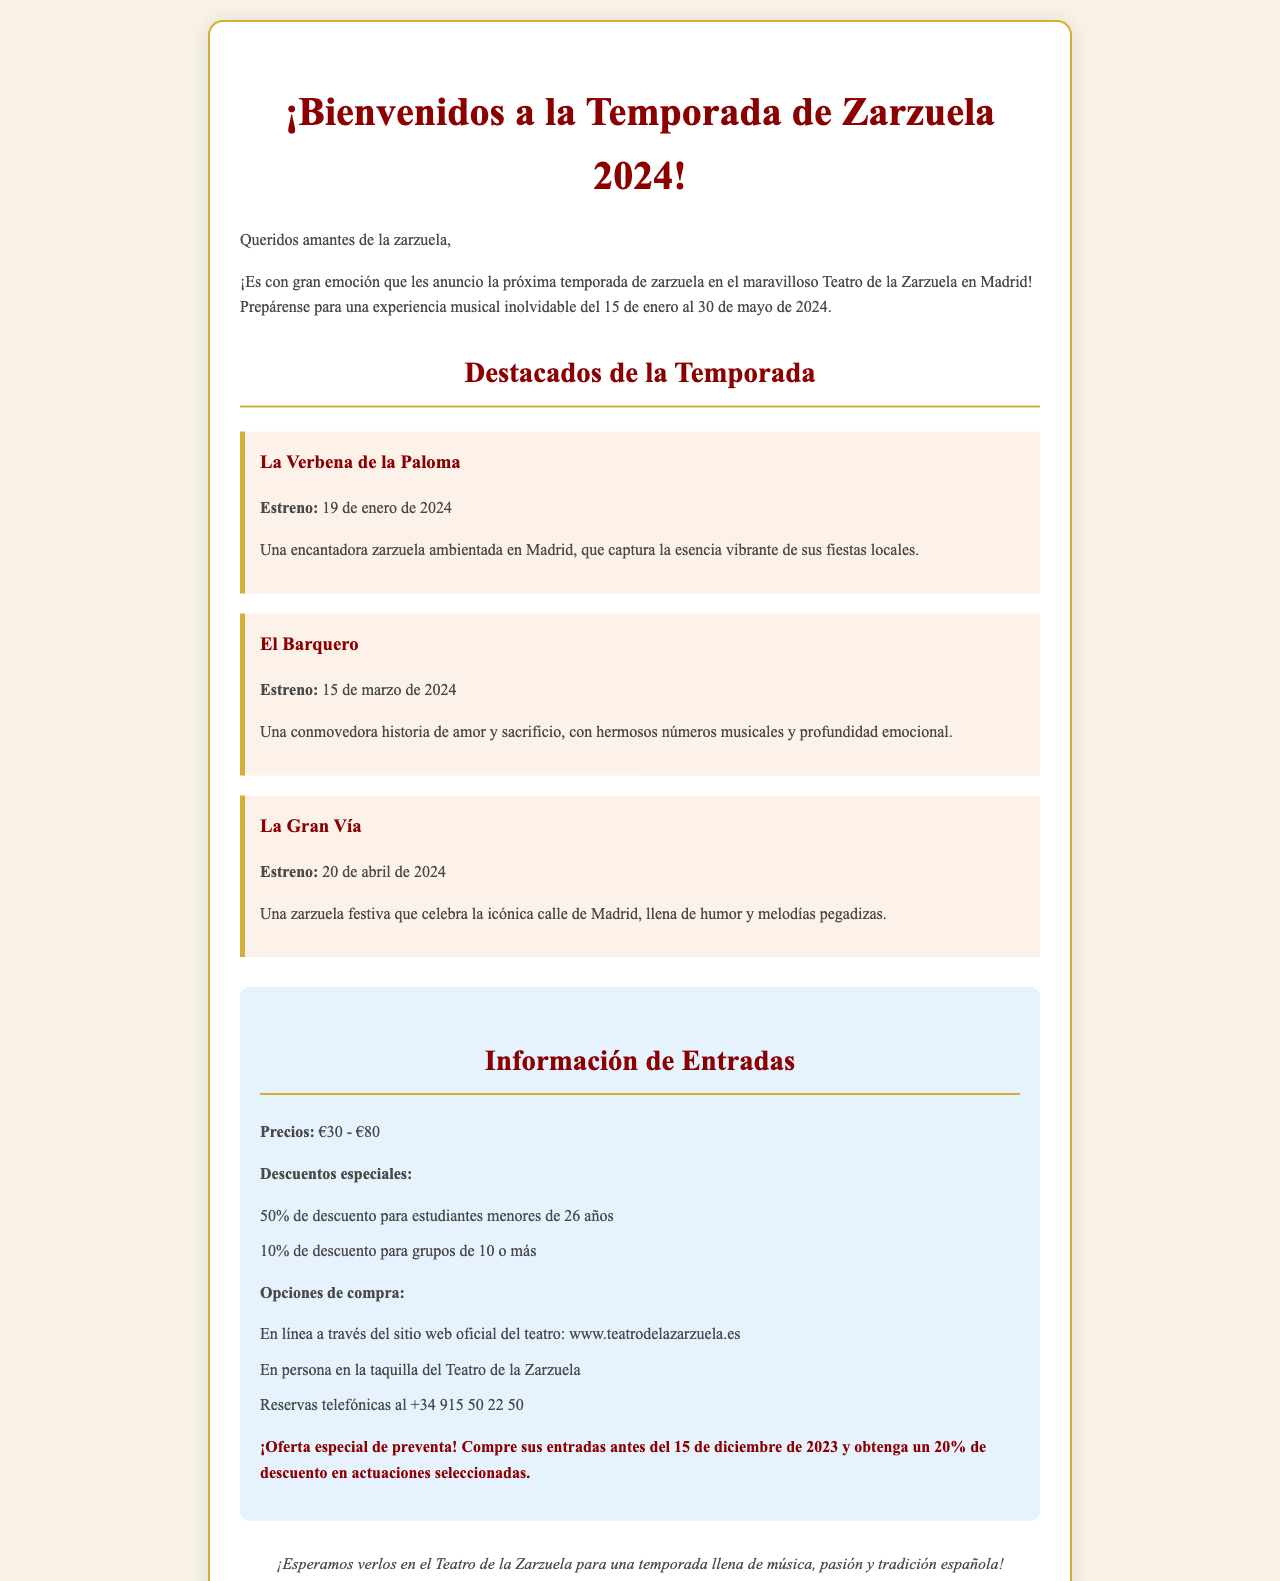¿Qué fechas abarca la temporada de zarzuela? La temporada comienza el 15 de enero y termina el 30 de mayo de 2024.
Answer: 15 de enero al 30 de mayo de 2024 ¿Cuál es el precio de las entradas? El documento menciona que los precios de las entradas varían entre €30 y €80.
Answer: €30 - €80 ¿Qué zarzuela se estrena el 19 de enero de 2024? Se refiere a "La Verbena de la Paloma", que es el estreno mencionado en esa fecha.
Answer: La Verbena de la Paloma ¿Cuál es el descuento para estudiantes menores de 26 años? El documento especifica que hay un 50% de descuento para estudiantes menores de 26 años.
Answer: 50% ¿Cómo se pueden comprar las entradas en persona? Las entradas se pueden adquirir en la taquilla del Teatro de la Zarzuela.
Answer: En persona en la taquilla del Teatro de la Zarzuela ¿Cuándo es la oferta especial de preventa? La oferta de preventa es válida hasta el 15 de diciembre de 2023.
Answer: 15 de diciembre de 2023 ¿Qué zarzuela se estrenará el 20 de abril de 2024? "La Gran Vía" se estrena esta fecha y se destaca en el documento.
Answer: La Gran Vía ¿Cuál es el número de teléfono para reservas? El documento proporciona el número de teléfono como +34 915 50 22 50.
Answer: +34 915 50 22 50 